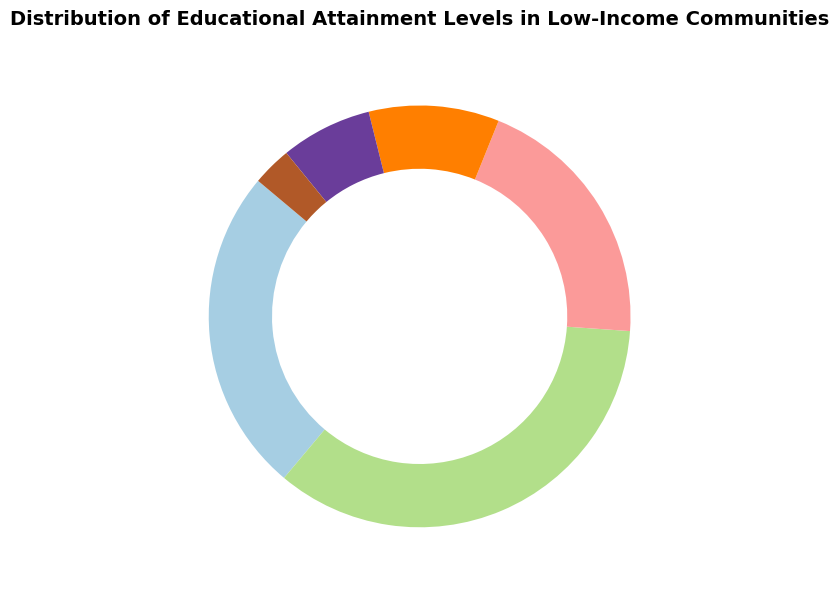Which educational attainment level has the highest percentage in low-income communities? Referring to the pie chart, the segment labeled "High School Diploma" occupies the largest portion of the pie, which indicates it has the highest percentage.
Answer: High School Diploma Which two educational attainment levels together make up more than half of the distribution? Adding the percentages of the two largest segments, "High School Diploma" (35%) and "No High School Diploma" (25%), we get 35% + 25% = 60%, which is more than half.
Answer: High School Diploma and No High School Diploma How much larger is the percentage of individuals with some college experience compared to those with a graduate degree? Finding the difference between "Some College" (20%) and "Graduate Degree" (3%) involves subtraction: 20% - 3% = 17%.
Answer: 17% What is the combined percentage of individuals with an Associate's Degree and a Bachelor's Degree? Adding the percentages for "Associate's Degree" (10%) and "Bachelor's Degree" (7%), we get 10% + 7% = 17%.
Answer: 17% Which educational attainment level has the smallest percentage in low-income communities? Observing the pie chart, the smallest segment is labeled "Graduate Degree" which represents the smallest percentage.
Answer: Graduate Degree Compare the combined percentage of those who have a high school diploma or less (including "No High School Diploma") to those with any college experience (including "Some College", "Associate's Degree", "Bachelor's Degree", and "Graduate Degree"). Which is higher? Adding the segments for "No High School Diploma" (25%) and "High School Diploma" (35%) gives 60%. Adding "Some College" (20%), "Associate's Degree" (10%), "Bachelor's Degree" (7%), and "Graduate Degree" (3%) gives 40%. The higher value is 60% for those with a high school diploma or less.
Answer: High school diploma or less Which segment of the pie chart is represented by the color that is placed in the middle of the color palette range? The segments use a color palette from light to dark, and the middle color typically would be equidistant from the lightest and darkest colors. In the default pie chart configuration, this usually corresponds to the segment for "Some College".
Answer: Some College 